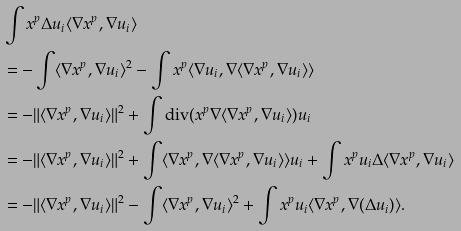Convert formula to latex. <formula><loc_0><loc_0><loc_500><loc_500>& \int x ^ { p } \Delta u _ { i } \langle \nabla x ^ { p } , \nabla u _ { i } \rangle \\ & = - \int \langle \nabla x ^ { p } , \nabla u _ { i } \rangle ^ { 2 } - \int x ^ { p } \langle \nabla u _ { i } , \nabla \langle \nabla x ^ { p } , \nabla u _ { i } \rangle \rangle \\ & = - \| \langle \nabla x ^ { p } , \nabla u _ { i } \rangle \| ^ { 2 } + \int \text {div} ( x ^ { p } \nabla \langle \nabla x ^ { p } , \nabla u _ { i } \rangle ) u _ { i } \\ & = - \| \langle \nabla x ^ { p } , \nabla u _ { i } \rangle \| ^ { 2 } + \int \langle \nabla x ^ { p } , \nabla \langle \nabla x ^ { p } , \nabla u _ { i } \rangle \rangle u _ { i } + \int x ^ { p } u _ { i } \Delta \langle \nabla x ^ { p } , \nabla u _ { i } \rangle \\ & = - \| \langle \nabla x ^ { p } , \nabla u _ { i } \rangle \| ^ { 2 } - \int \langle \nabla x ^ { p } , \nabla u _ { i } \rangle ^ { 2 } + \int x ^ { p } u _ { i } \langle \nabla x ^ { p } , \nabla ( \Delta u _ { i } ) \rangle . \\</formula> 